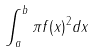<formula> <loc_0><loc_0><loc_500><loc_500>\int _ { a } ^ { b } \pi f ( x ) ^ { 2 } d x</formula> 